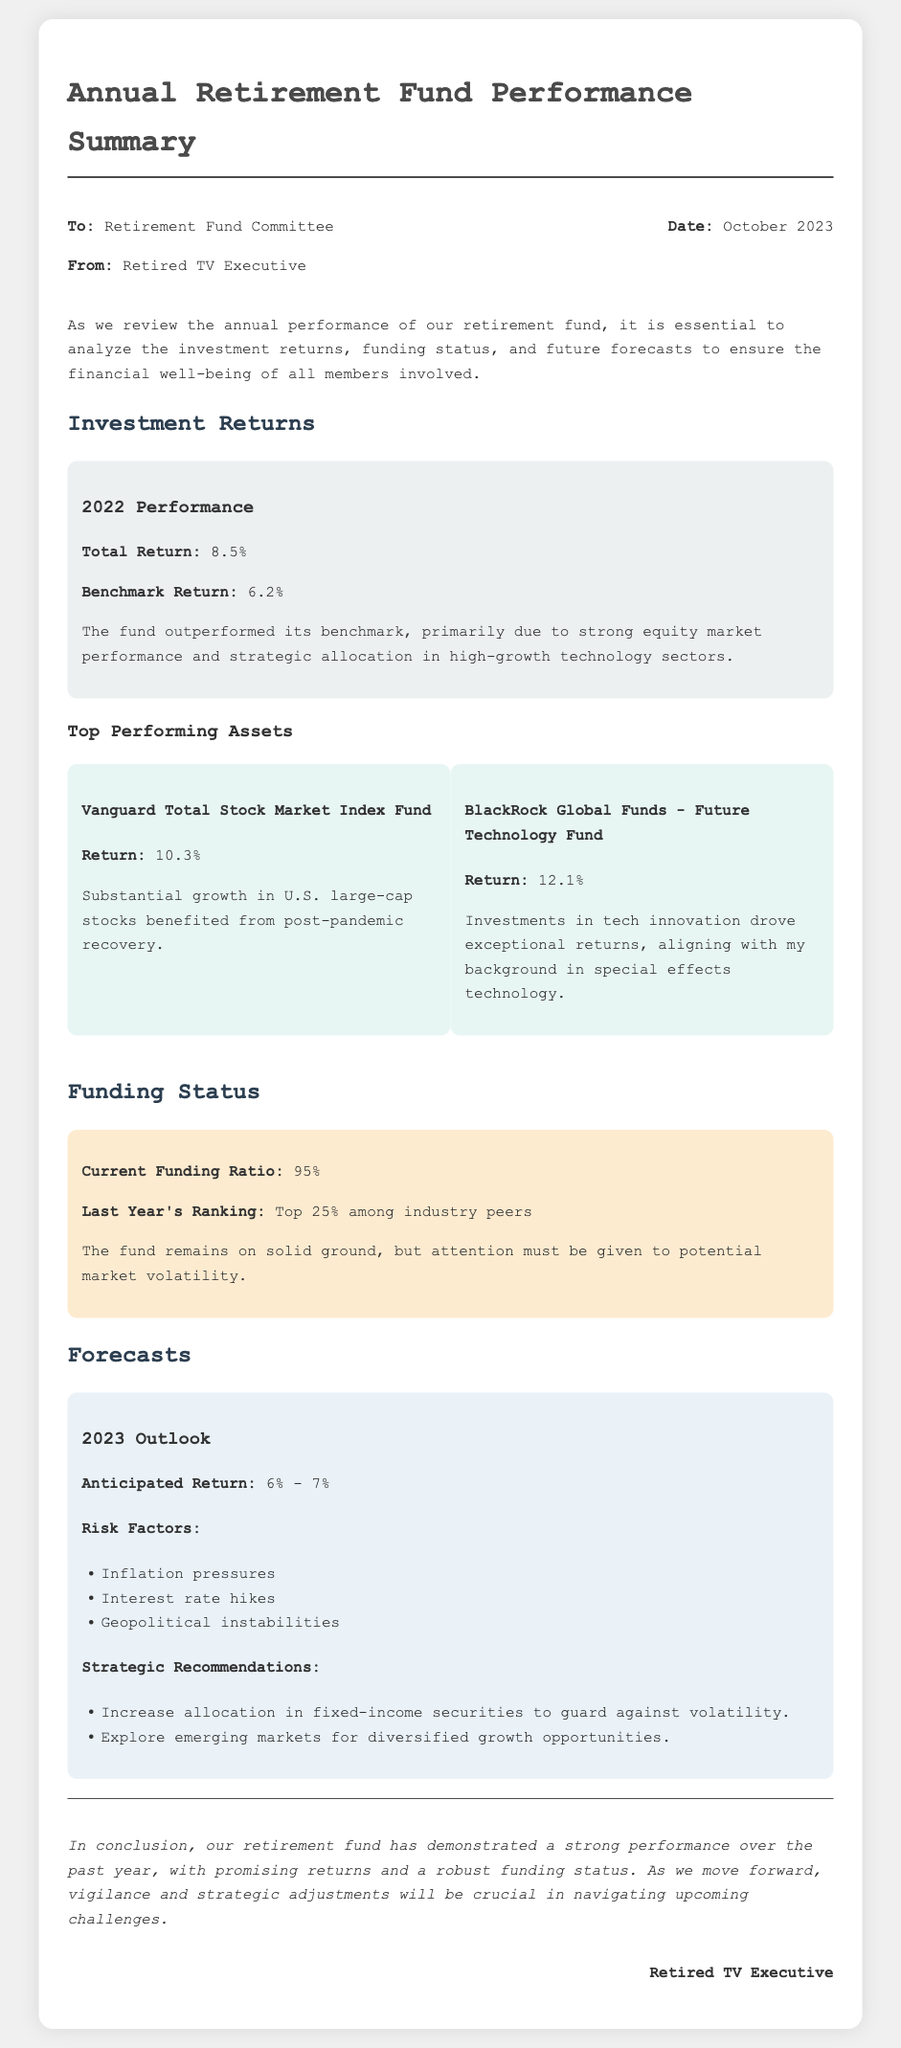what is the total return for 2022? The total return for 2022 is listed in the document, which is 8.5%.
Answer: 8.5% what is the anticipated return range for 2023? The anticipated return range for 2023 can be found in the forecasts section, which states 6% - 7%.
Answer: 6% - 7% what is the current funding ratio? The current funding ratio is mentioned in the funding status section as 95%.
Answer: 95% which fund had the highest return? The fund with the highest return is specified in the top performing assets section, which is the BlackRock Global Funds - Future Technology Fund at 12.1%.
Answer: BlackRock Global Funds - Future Technology Fund what are two risk factors mentioned in the forecast? Two risk factors are listed in the forecasts, including inflation pressures and interest rate hikes.
Answer: inflation pressures, interest rate hikes what was last year's ranking among industry peers? Last year's ranking is given as top 25% among industry peers in the funding status section.
Answer: Top 25% what significant technology sector benefited the fund's performance? The sector that benefited the fund's performance is mentioned as high-growth technology sectors in the investment returns section.
Answer: high-growth technology sectors what strategic recommendation is given to guard against volatility? A strategic recommendation to guard against volatility is provided in the forecasts, which is to increase allocation in fixed-income securities.
Answer: increase allocation in fixed-income securities what is the memo's date? The date of the memo is specified at the top, in October 2023.
Answer: October 2023 